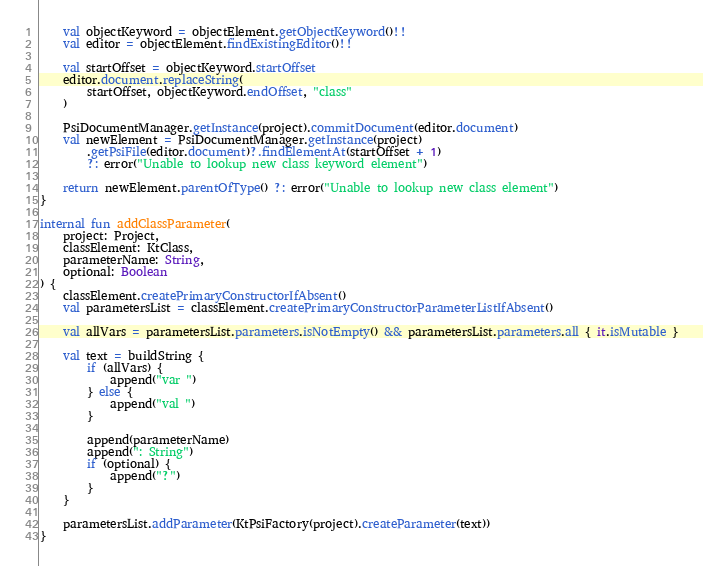<code> <loc_0><loc_0><loc_500><loc_500><_Kotlin_>    val objectKeyword = objectElement.getObjectKeyword()!!
    val editor = objectElement.findExistingEditor()!!

    val startOffset = objectKeyword.startOffset
    editor.document.replaceString(
        startOffset, objectKeyword.endOffset, "class"
    )

    PsiDocumentManager.getInstance(project).commitDocument(editor.document)
    val newElement = PsiDocumentManager.getInstance(project)
        .getPsiFile(editor.document)?.findElementAt(startOffset + 1)
        ?: error("Unable to lookup new class keyword element")

    return newElement.parentOfType() ?: error("Unable to lookup new class element")
}

internal fun addClassParameter(
    project: Project,
    classElement: KtClass,
    parameterName: String,
    optional: Boolean
) {
    classElement.createPrimaryConstructorIfAbsent()
    val parametersList = classElement.createPrimaryConstructorParameterListIfAbsent()

    val allVars = parametersList.parameters.isNotEmpty() && parametersList.parameters.all { it.isMutable }

    val text = buildString {
        if (allVars) {
            append("var ")
        } else {
            append("val ")
        }

        append(parameterName)
        append(": String")
        if (optional) {
            append("?")
        }
    }

    parametersList.addParameter(KtPsiFactory(project).createParameter(text))
}</code> 